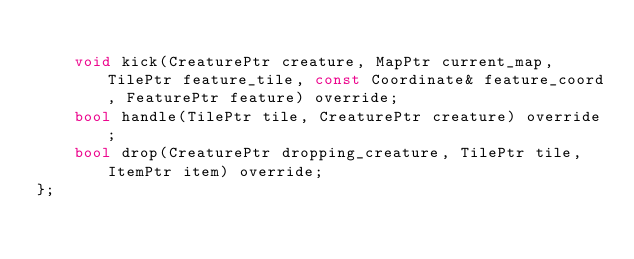Convert code to text. <code><loc_0><loc_0><loc_500><loc_500><_C++_>
    void kick(CreaturePtr creature, MapPtr current_map, TilePtr feature_tile, const Coordinate& feature_coord, FeaturePtr feature) override;
    bool handle(TilePtr tile, CreaturePtr creature) override;
    bool drop(CreaturePtr dropping_creature, TilePtr tile, ItemPtr item) override;
};

</code> 